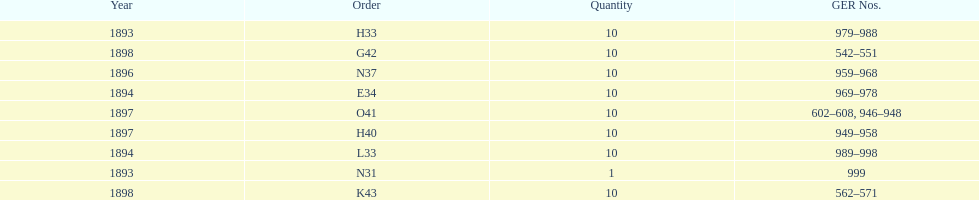What is the total number of locomotives made during this time? 81. 